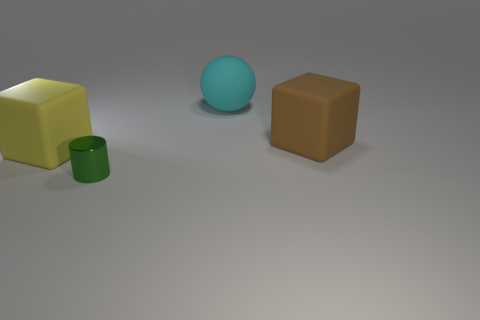Add 1 large rubber cubes. How many objects exist? 5 Subtract all balls. How many objects are left? 3 Add 4 large yellow rubber things. How many large yellow rubber things exist? 5 Subtract 0 brown balls. How many objects are left? 4 Subtract all big cyan rubber things. Subtract all big cubes. How many objects are left? 1 Add 4 rubber blocks. How many rubber blocks are left? 6 